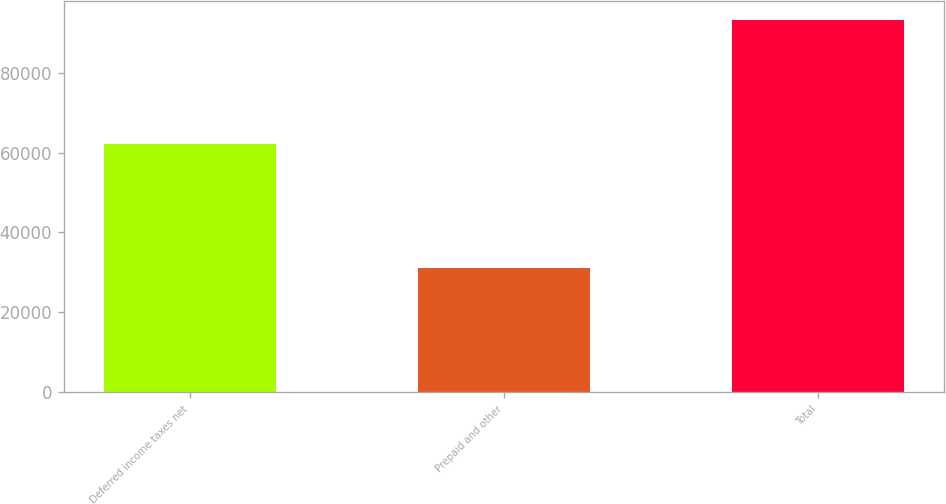Convert chart. <chart><loc_0><loc_0><loc_500><loc_500><bar_chart><fcel>Deferred income taxes net<fcel>Prepaid and other<fcel>Total<nl><fcel>62122<fcel>31175<fcel>93297<nl></chart> 